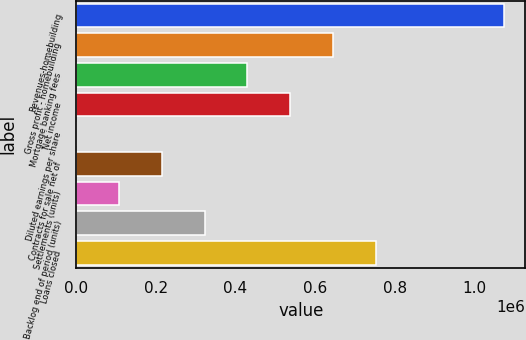Convert chart. <chart><loc_0><loc_0><loc_500><loc_500><bar_chart><fcel>Revenues-homebuilding<fcel>Gross profit - homebuilding<fcel>Mortgage banking fees<fcel>Net income<fcel>Diluted earnings per share<fcel>Contracts for sale net of<fcel>Settlements (units)<fcel>Backlog end of period (units)<fcel>Loans closed<nl><fcel>1.07511e+06<fcel>645071<fcel>430052<fcel>537561<fcel>12.96<fcel>215032<fcel>107523<fcel>322542<fcel>752581<nl></chart> 